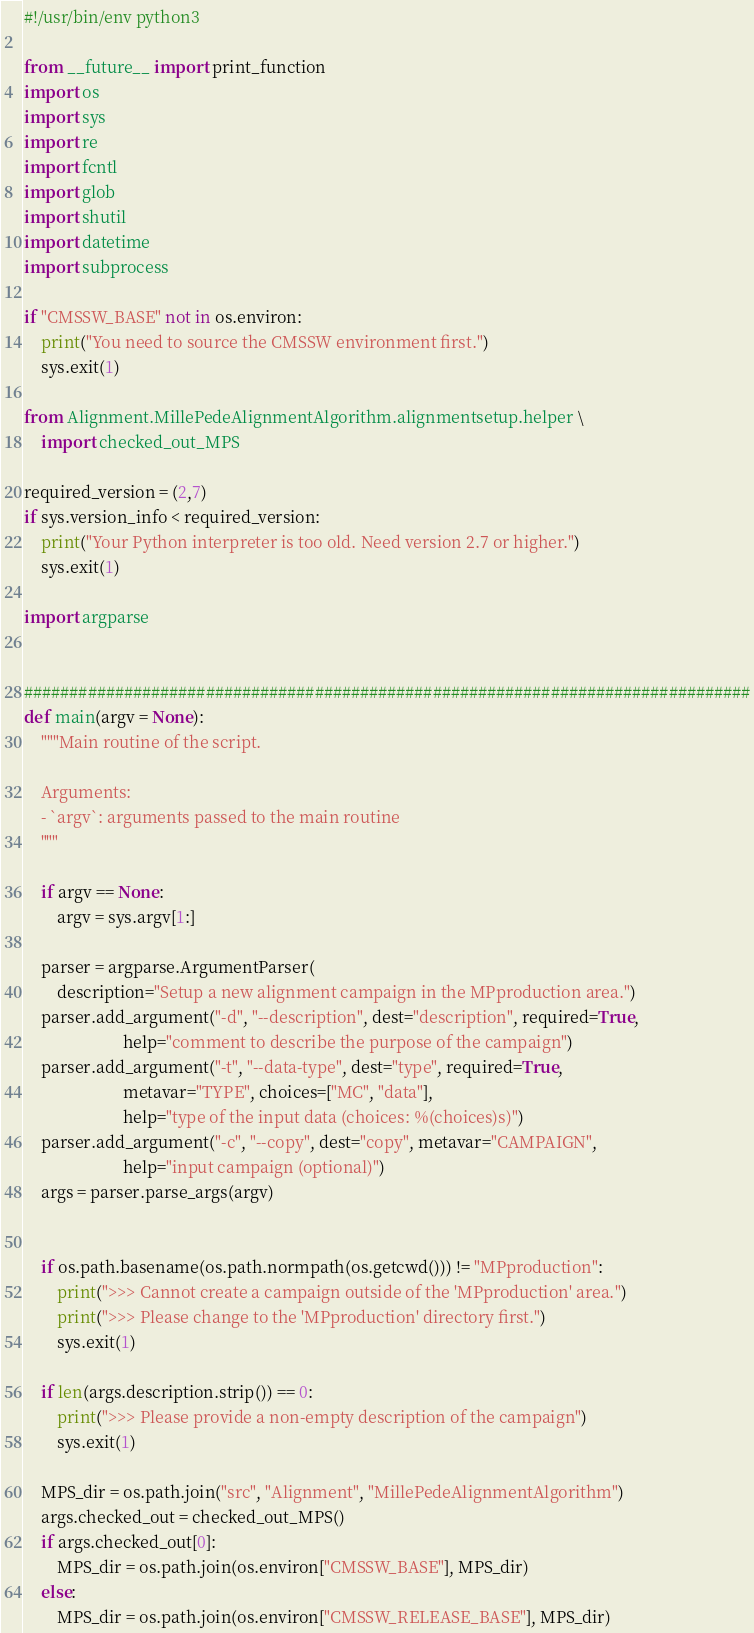Convert code to text. <code><loc_0><loc_0><loc_500><loc_500><_Python_>#!/usr/bin/env python3

from __future__ import print_function
import os
import sys
import re
import fcntl
import glob
import shutil
import datetime
import subprocess

if "CMSSW_BASE" not in os.environ:
    print("You need to source the CMSSW environment first.")
    sys.exit(1)

from Alignment.MillePedeAlignmentAlgorithm.alignmentsetup.helper \
    import checked_out_MPS

required_version = (2,7)
if sys.version_info < required_version:
    print("Your Python interpreter is too old. Need version 2.7 or higher.")
    sys.exit(1)

import argparse


################################################################################
def main(argv = None):
    """Main routine of the script.

    Arguments:
    - `argv`: arguments passed to the main routine
    """

    if argv == None:
        argv = sys.argv[1:]

    parser = argparse.ArgumentParser(
        description="Setup a new alignment campaign in the MPproduction area.")
    parser.add_argument("-d", "--description", dest="description", required=True,
                        help="comment to describe the purpose of the campaign")
    parser.add_argument("-t", "--data-type", dest="type", required=True,
                        metavar="TYPE", choices=["MC", "data"],
                        help="type of the input data (choices: %(choices)s)")
    parser.add_argument("-c", "--copy", dest="copy", metavar="CAMPAIGN",
                        help="input campaign (optional)")
    args = parser.parse_args(argv)


    if os.path.basename(os.path.normpath(os.getcwd())) != "MPproduction":
        print(">>> Cannot create a campaign outside of the 'MPproduction' area.")
        print(">>> Please change to the 'MPproduction' directory first.")
        sys.exit(1)

    if len(args.description.strip()) == 0:
        print(">>> Please provide a non-empty description of the campaign")
        sys.exit(1)

    MPS_dir = os.path.join("src", "Alignment", "MillePedeAlignmentAlgorithm")
    args.checked_out = checked_out_MPS()
    if args.checked_out[0]:
        MPS_dir = os.path.join(os.environ["CMSSW_BASE"], MPS_dir)
    else:
        MPS_dir = os.path.join(os.environ["CMSSW_RELEASE_BASE"], MPS_dir)</code> 